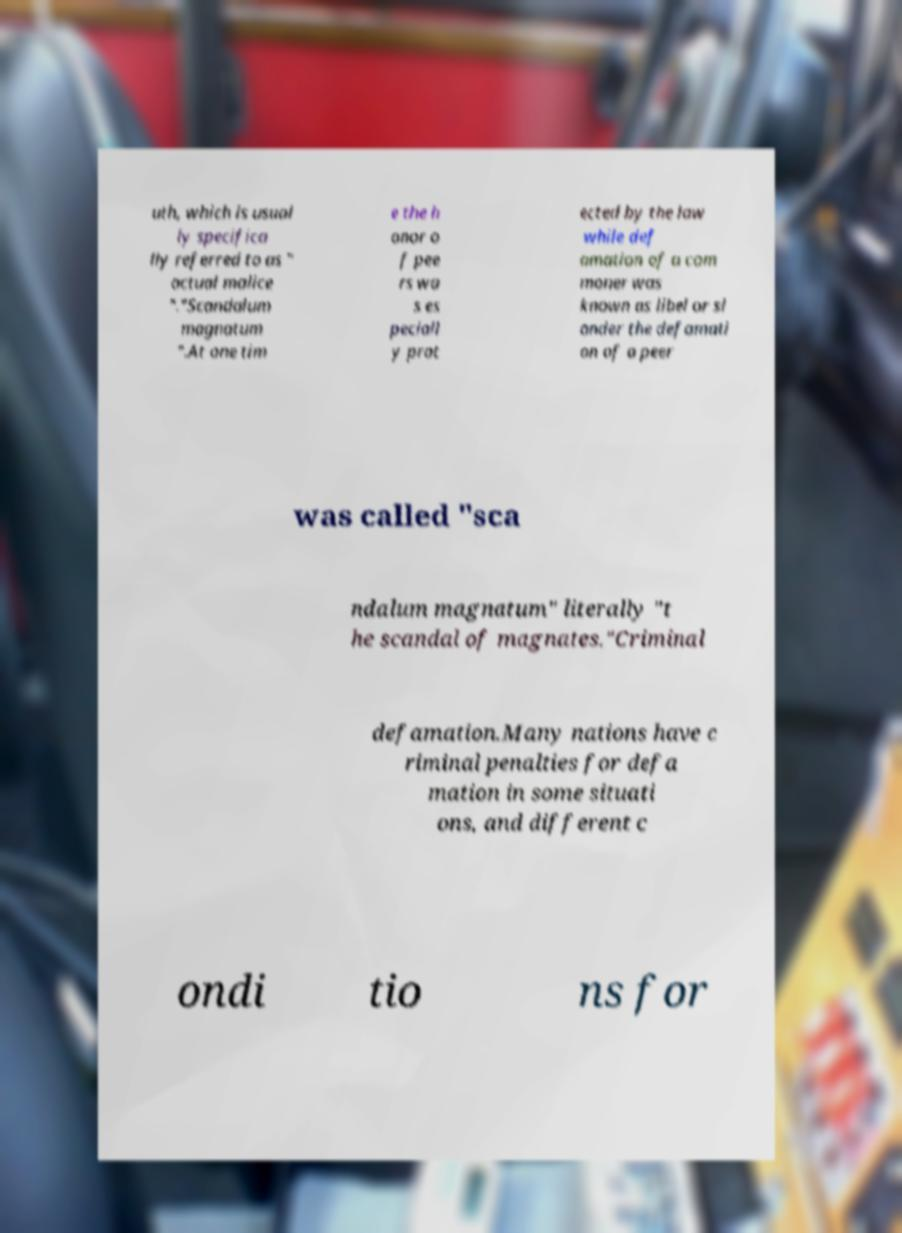Can you read and provide the text displayed in the image?This photo seems to have some interesting text. Can you extract and type it out for me? uth, which is usual ly specifica lly referred to as " actual malice "."Scandalum magnatum ".At one tim e the h onor o f pee rs wa s es peciall y prot ected by the law while def amation of a com moner was known as libel or sl ander the defamati on of a peer was called "sca ndalum magnatum" literally "t he scandal of magnates."Criminal defamation.Many nations have c riminal penalties for defa mation in some situati ons, and different c ondi tio ns for 